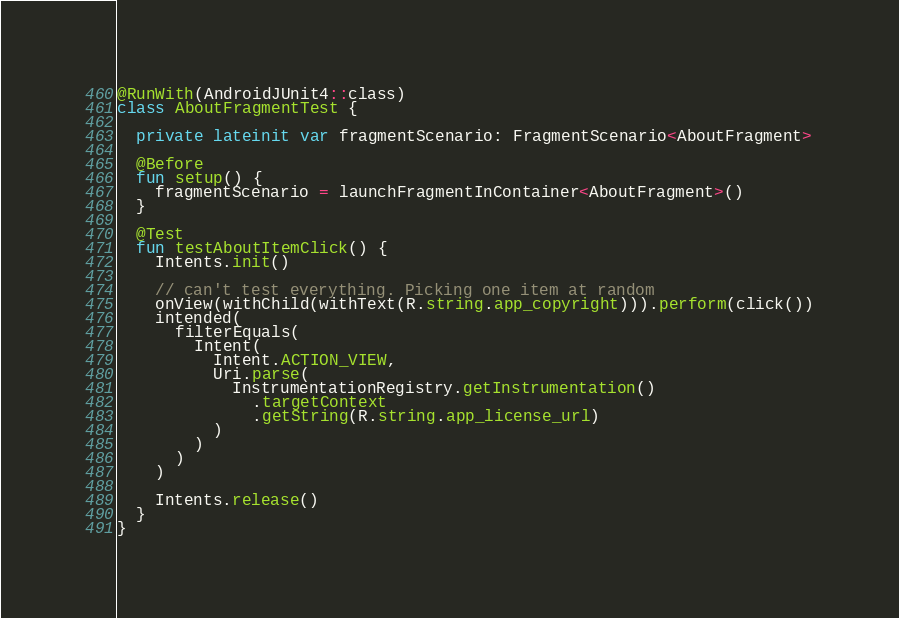<code> <loc_0><loc_0><loc_500><loc_500><_Kotlin_>
@RunWith(AndroidJUnit4::class)
class AboutFragmentTest {

  private lateinit var fragmentScenario: FragmentScenario<AboutFragment>

  @Before
  fun setup() {
    fragmentScenario = launchFragmentInContainer<AboutFragment>()
  }

  @Test
  fun testAboutItemClick() {
    Intents.init()

    // can't test everything. Picking one item at random
    onView(withChild(withText(R.string.app_copyright))).perform(click())
    intended(
      filterEquals(
        Intent(
          Intent.ACTION_VIEW,
          Uri.parse(
            InstrumentationRegistry.getInstrumentation()
              .targetContext
              .getString(R.string.app_license_url)
          )
        )
      )
    )

    Intents.release()
  }
}
</code> 